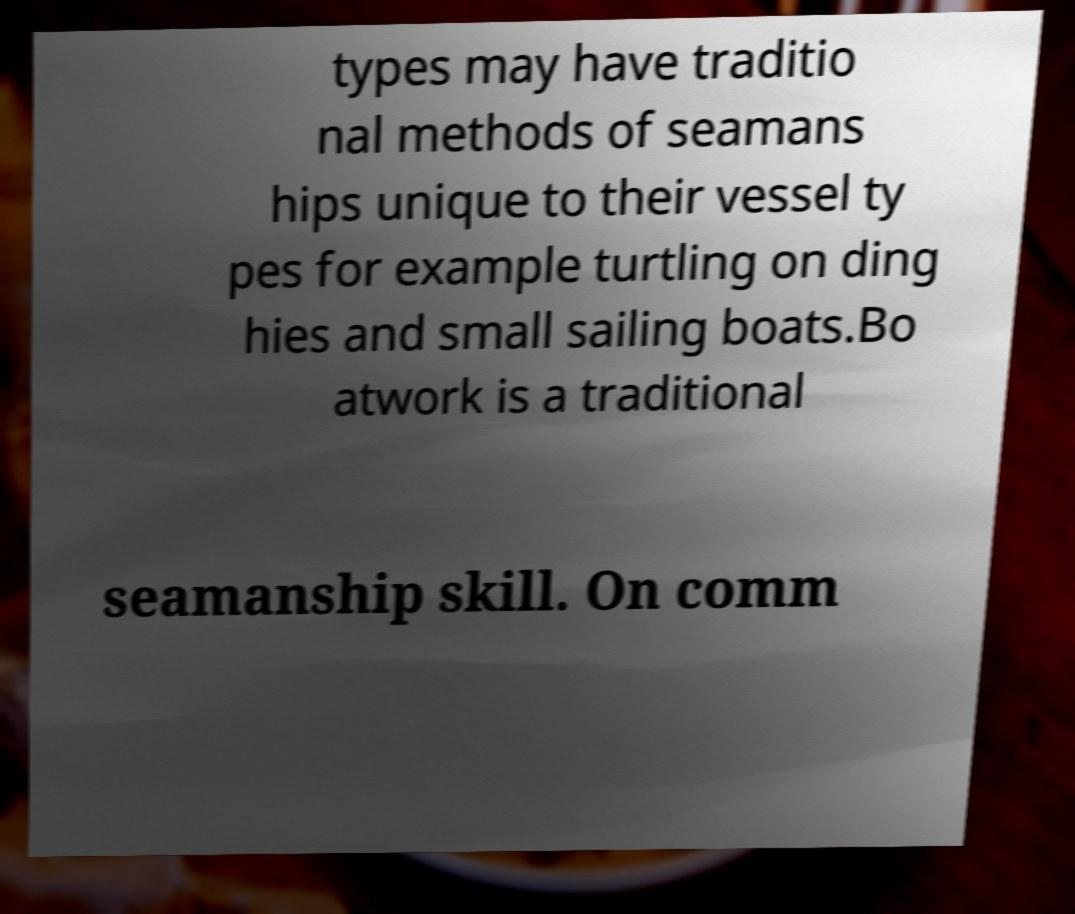Could you extract and type out the text from this image? types may have traditio nal methods of seamans hips unique to their vessel ty pes for example turtling on ding hies and small sailing boats.Bo atwork is a traditional seamanship skill. On comm 